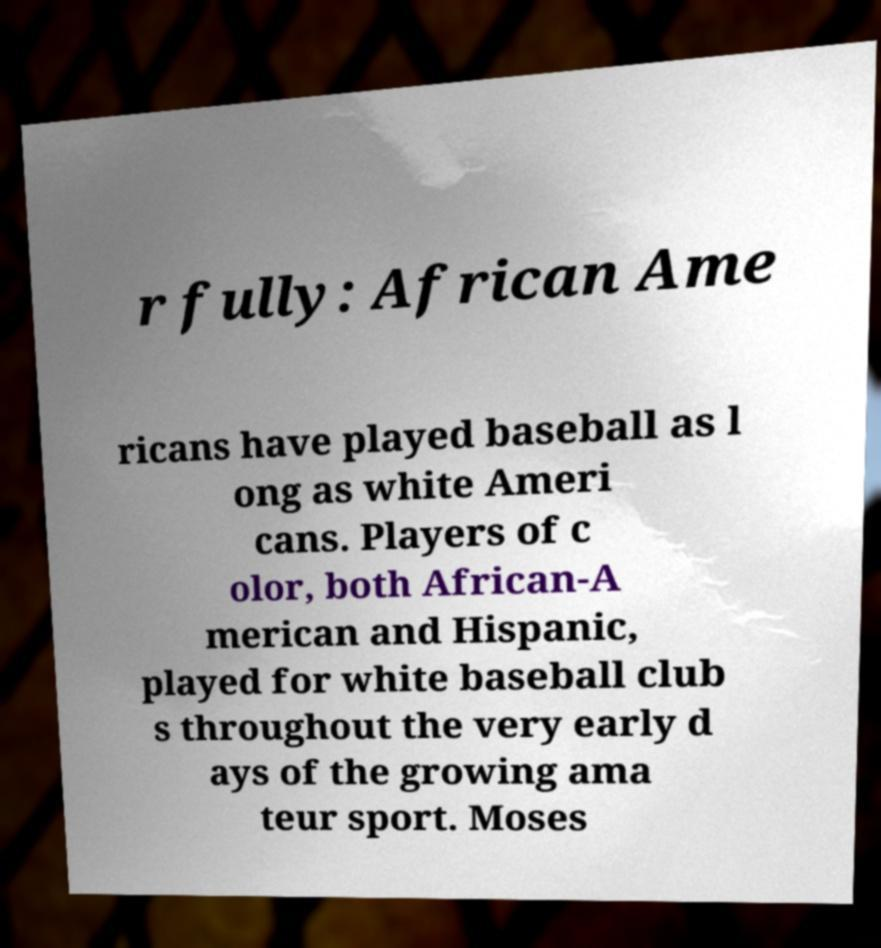Please identify and transcribe the text found in this image. r fully: African Ame ricans have played baseball as l ong as white Ameri cans. Players of c olor, both African-A merican and Hispanic, played for white baseball club s throughout the very early d ays of the growing ama teur sport. Moses 